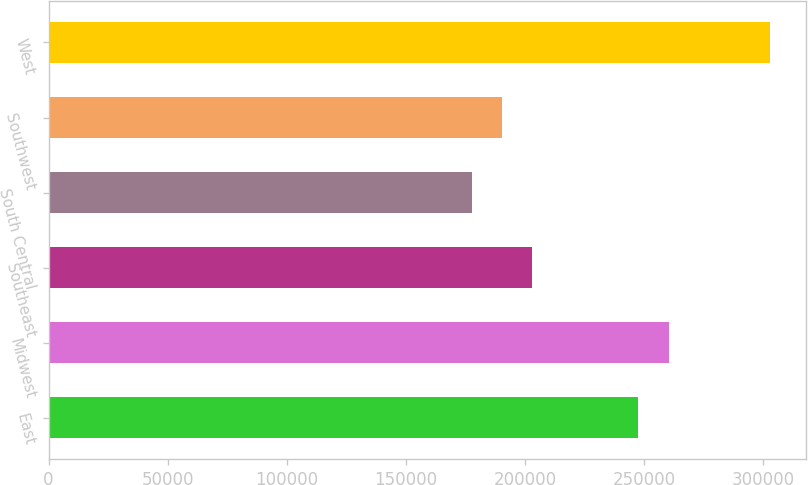Convert chart to OTSL. <chart><loc_0><loc_0><loc_500><loc_500><bar_chart><fcel>East<fcel>Midwest<fcel>Southeast<fcel>South Central<fcel>Southwest<fcel>West<nl><fcel>247400<fcel>260400<fcel>202900<fcel>177900<fcel>190400<fcel>302900<nl></chart> 